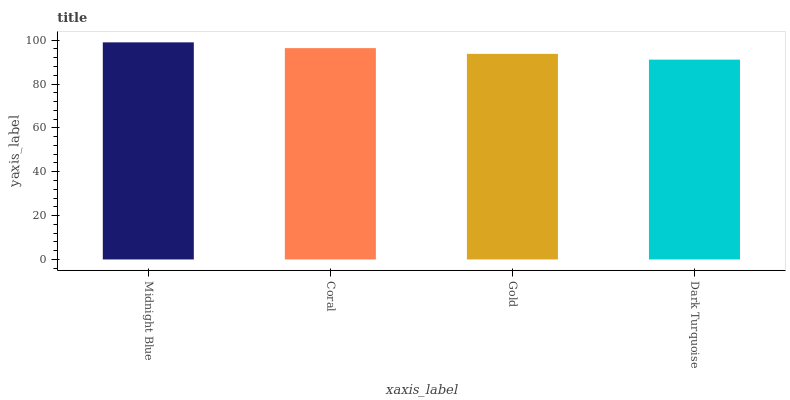Is Dark Turquoise the minimum?
Answer yes or no. Yes. Is Midnight Blue the maximum?
Answer yes or no. Yes. Is Coral the minimum?
Answer yes or no. No. Is Coral the maximum?
Answer yes or no. No. Is Midnight Blue greater than Coral?
Answer yes or no. Yes. Is Coral less than Midnight Blue?
Answer yes or no. Yes. Is Coral greater than Midnight Blue?
Answer yes or no. No. Is Midnight Blue less than Coral?
Answer yes or no. No. Is Coral the high median?
Answer yes or no. Yes. Is Gold the low median?
Answer yes or no. Yes. Is Dark Turquoise the high median?
Answer yes or no. No. Is Coral the low median?
Answer yes or no. No. 